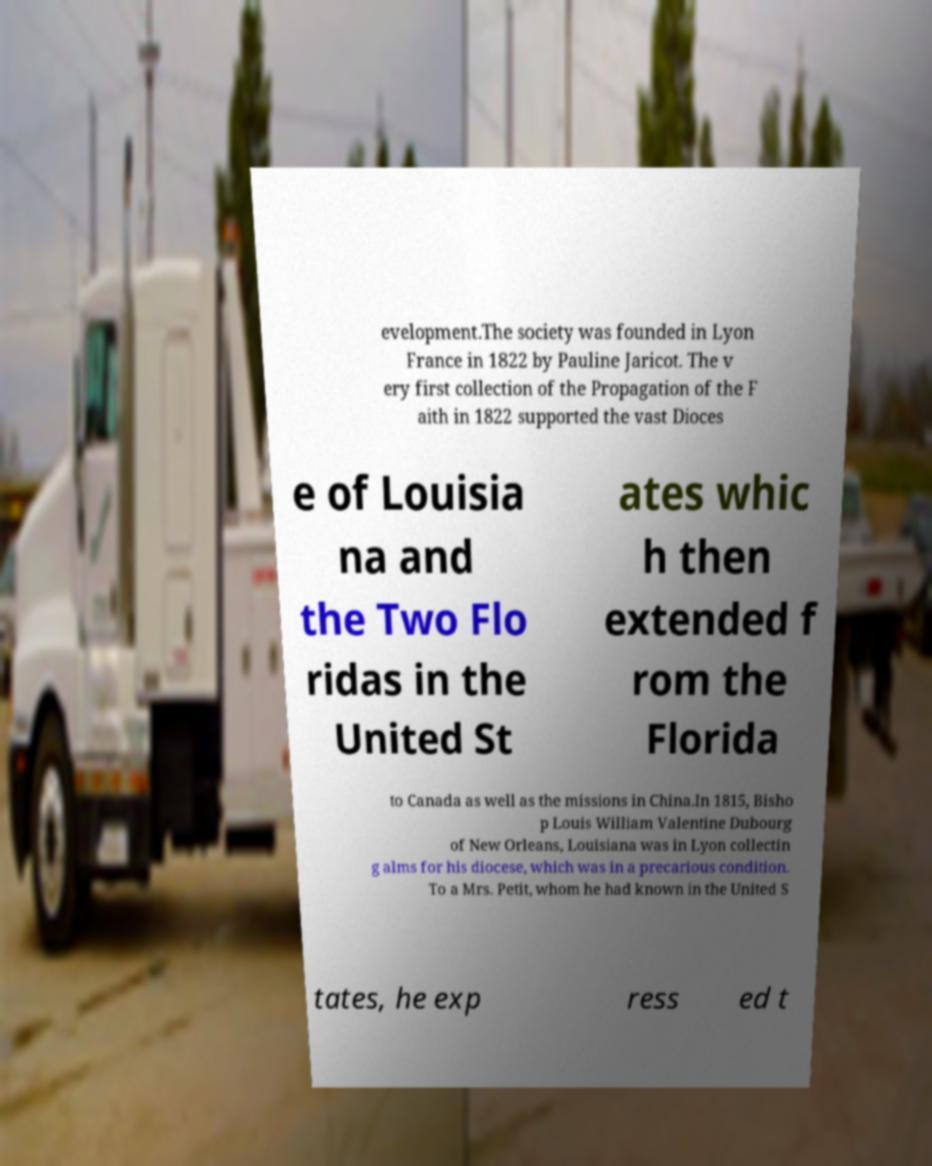For documentation purposes, I need the text within this image transcribed. Could you provide that? evelopment.The society was founded in Lyon France in 1822 by Pauline Jaricot. The v ery first collection of the Propagation of the F aith in 1822 supported the vast Dioces e of Louisia na and the Two Flo ridas in the United St ates whic h then extended f rom the Florida to Canada as well as the missions in China.In 1815, Bisho p Louis William Valentine Dubourg of New Orleans, Louisiana was in Lyon collectin g alms for his diocese, which was in a precarious condition. To a Mrs. Petit, whom he had known in the United S tates, he exp ress ed t 